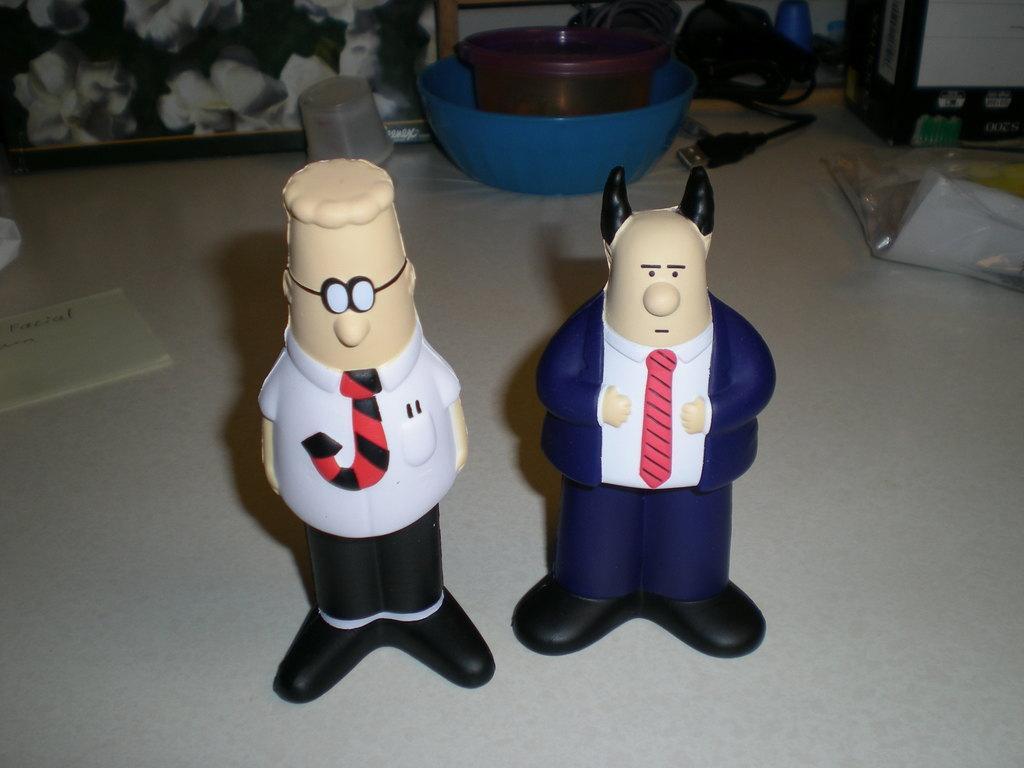Can you describe this image briefly? Here we can see toys, paper, plastic cover, cables, box, and baskets. There is a frame. 